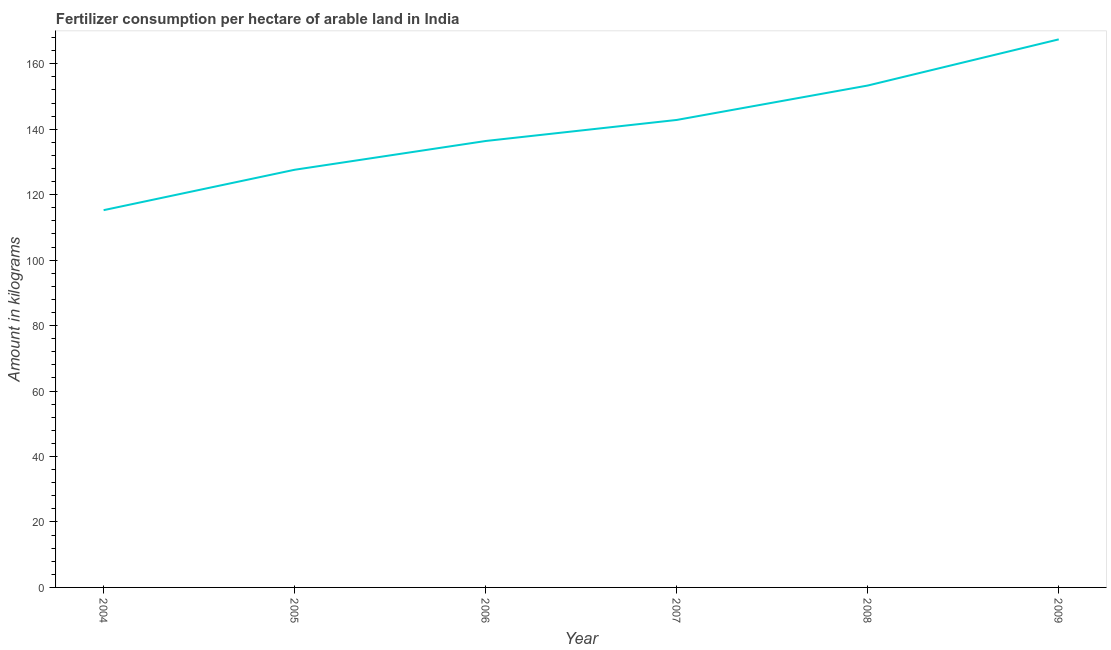What is the amount of fertilizer consumption in 2004?
Offer a very short reply. 115.27. Across all years, what is the maximum amount of fertilizer consumption?
Make the answer very short. 167.46. Across all years, what is the minimum amount of fertilizer consumption?
Provide a succinct answer. 115.27. In which year was the amount of fertilizer consumption minimum?
Your response must be concise. 2004. What is the sum of the amount of fertilizer consumption?
Provide a short and direct response. 842.93. What is the difference between the amount of fertilizer consumption in 2005 and 2007?
Make the answer very short. -15.22. What is the average amount of fertilizer consumption per year?
Keep it short and to the point. 140.49. What is the median amount of fertilizer consumption?
Offer a very short reply. 139.62. In how many years, is the amount of fertilizer consumption greater than 124 kg?
Keep it short and to the point. 5. What is the ratio of the amount of fertilizer consumption in 2005 to that in 2007?
Make the answer very short. 0.89. Is the amount of fertilizer consumption in 2005 less than that in 2008?
Your answer should be compact. Yes. What is the difference between the highest and the second highest amount of fertilizer consumption?
Offer a terse response. 14.11. What is the difference between the highest and the lowest amount of fertilizer consumption?
Give a very brief answer. 52.19. Does the amount of fertilizer consumption monotonically increase over the years?
Provide a succinct answer. Yes. How many lines are there?
Provide a succinct answer. 1. What is the difference between two consecutive major ticks on the Y-axis?
Offer a terse response. 20. Are the values on the major ticks of Y-axis written in scientific E-notation?
Your response must be concise. No. Does the graph contain any zero values?
Offer a terse response. No. What is the title of the graph?
Provide a succinct answer. Fertilizer consumption per hectare of arable land in India . What is the label or title of the Y-axis?
Ensure brevity in your answer.  Amount in kilograms. What is the Amount in kilograms of 2004?
Your answer should be compact. 115.27. What is the Amount in kilograms in 2005?
Keep it short and to the point. 127.61. What is the Amount in kilograms in 2006?
Give a very brief answer. 136.4. What is the Amount in kilograms of 2007?
Provide a short and direct response. 142.84. What is the Amount in kilograms in 2008?
Give a very brief answer. 153.35. What is the Amount in kilograms in 2009?
Your response must be concise. 167.46. What is the difference between the Amount in kilograms in 2004 and 2005?
Your answer should be very brief. -12.34. What is the difference between the Amount in kilograms in 2004 and 2006?
Keep it short and to the point. -21.13. What is the difference between the Amount in kilograms in 2004 and 2007?
Provide a succinct answer. -27.56. What is the difference between the Amount in kilograms in 2004 and 2008?
Make the answer very short. -38.08. What is the difference between the Amount in kilograms in 2004 and 2009?
Offer a very short reply. -52.19. What is the difference between the Amount in kilograms in 2005 and 2006?
Keep it short and to the point. -8.79. What is the difference between the Amount in kilograms in 2005 and 2007?
Give a very brief answer. -15.22. What is the difference between the Amount in kilograms in 2005 and 2008?
Give a very brief answer. -25.73. What is the difference between the Amount in kilograms in 2005 and 2009?
Make the answer very short. -39.84. What is the difference between the Amount in kilograms in 2006 and 2007?
Make the answer very short. -6.43. What is the difference between the Amount in kilograms in 2006 and 2008?
Make the answer very short. -16.95. What is the difference between the Amount in kilograms in 2006 and 2009?
Ensure brevity in your answer.  -31.05. What is the difference between the Amount in kilograms in 2007 and 2008?
Offer a very short reply. -10.51. What is the difference between the Amount in kilograms in 2007 and 2009?
Make the answer very short. -24.62. What is the difference between the Amount in kilograms in 2008 and 2009?
Your response must be concise. -14.11. What is the ratio of the Amount in kilograms in 2004 to that in 2005?
Make the answer very short. 0.9. What is the ratio of the Amount in kilograms in 2004 to that in 2006?
Provide a succinct answer. 0.84. What is the ratio of the Amount in kilograms in 2004 to that in 2007?
Offer a terse response. 0.81. What is the ratio of the Amount in kilograms in 2004 to that in 2008?
Provide a short and direct response. 0.75. What is the ratio of the Amount in kilograms in 2004 to that in 2009?
Ensure brevity in your answer.  0.69. What is the ratio of the Amount in kilograms in 2005 to that in 2006?
Offer a terse response. 0.94. What is the ratio of the Amount in kilograms in 2005 to that in 2007?
Keep it short and to the point. 0.89. What is the ratio of the Amount in kilograms in 2005 to that in 2008?
Your response must be concise. 0.83. What is the ratio of the Amount in kilograms in 2005 to that in 2009?
Your response must be concise. 0.76. What is the ratio of the Amount in kilograms in 2006 to that in 2007?
Make the answer very short. 0.95. What is the ratio of the Amount in kilograms in 2006 to that in 2008?
Keep it short and to the point. 0.89. What is the ratio of the Amount in kilograms in 2006 to that in 2009?
Offer a terse response. 0.81. What is the ratio of the Amount in kilograms in 2007 to that in 2008?
Offer a terse response. 0.93. What is the ratio of the Amount in kilograms in 2007 to that in 2009?
Offer a very short reply. 0.85. What is the ratio of the Amount in kilograms in 2008 to that in 2009?
Keep it short and to the point. 0.92. 